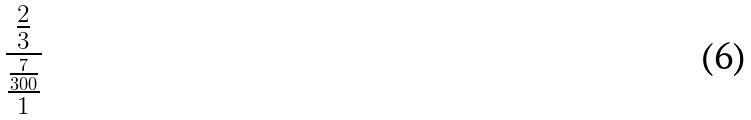<formula> <loc_0><loc_0><loc_500><loc_500>\frac { \frac { 2 } { 3 } } { \frac { \frac { 7 } { 3 0 0 } } { 1 } }</formula> 